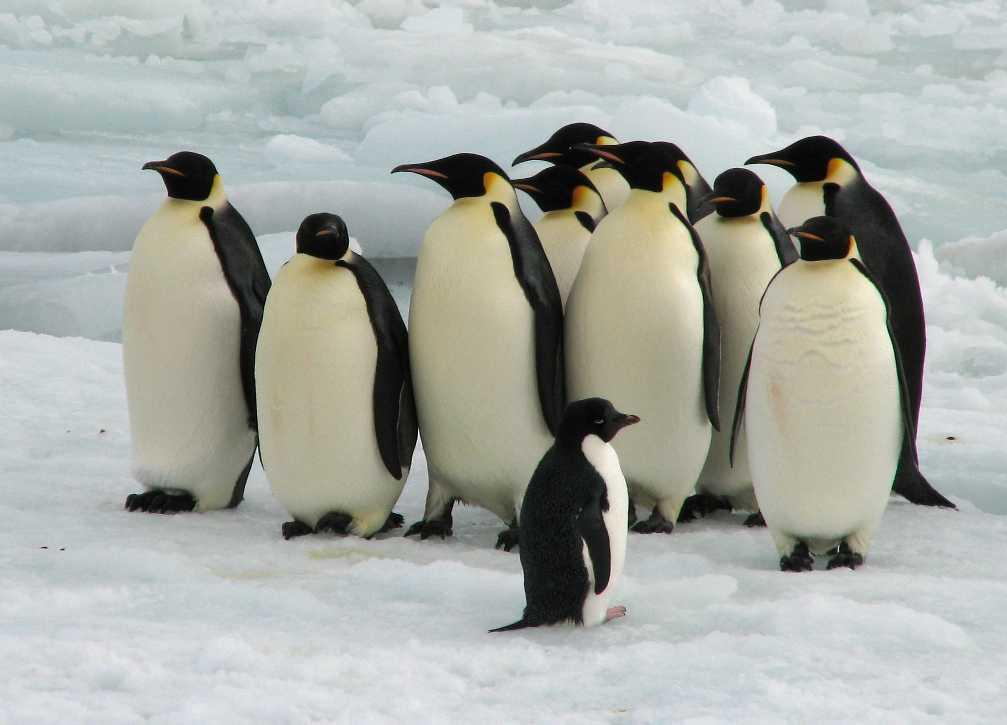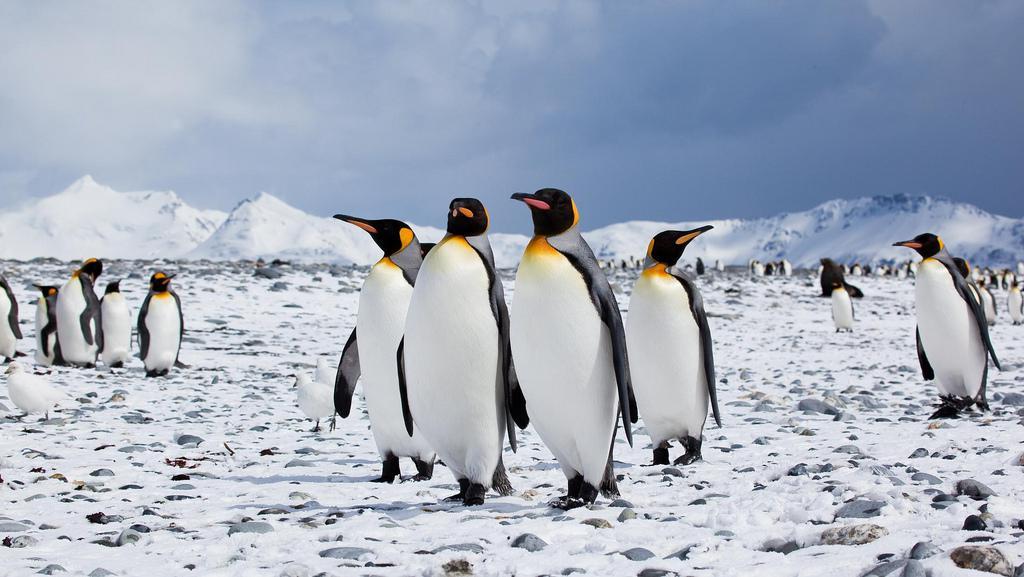The first image is the image on the left, the second image is the image on the right. Considering the images on both sides, is "One of the images features a penguin who is obviously young - still a chick!" valid? Answer yes or no. Yes. The first image is the image on the left, the second image is the image on the right. Considering the images on both sides, is "The image on the left shows no more than 7 penguins." valid? Answer yes or no. No. 